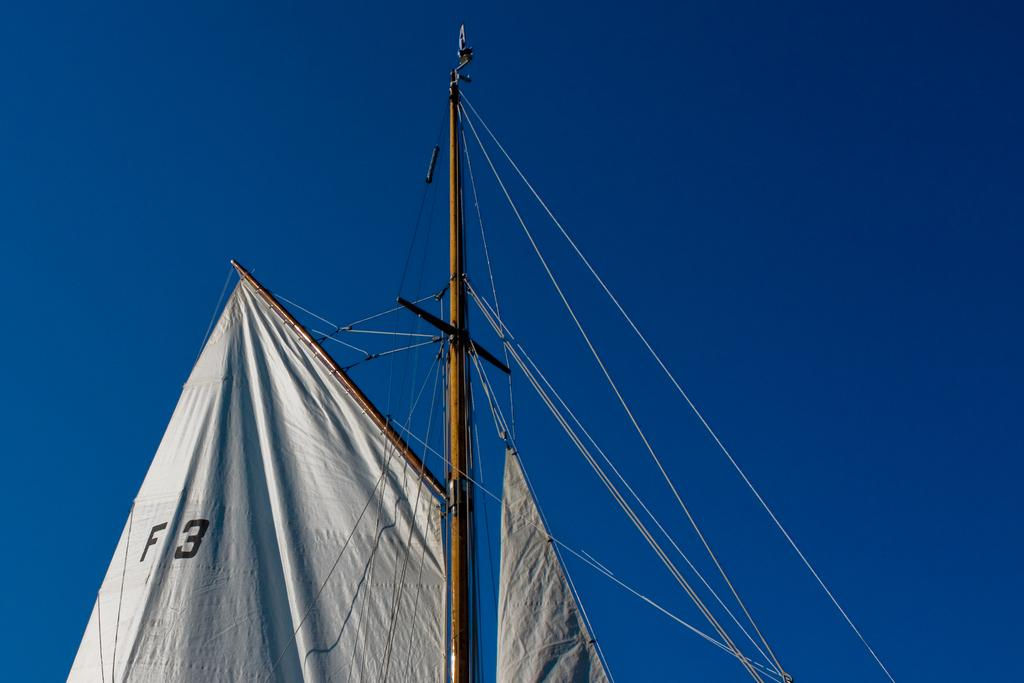<image>
Share a concise interpretation of the image provided. White sail which says F3 hanging in the air. 